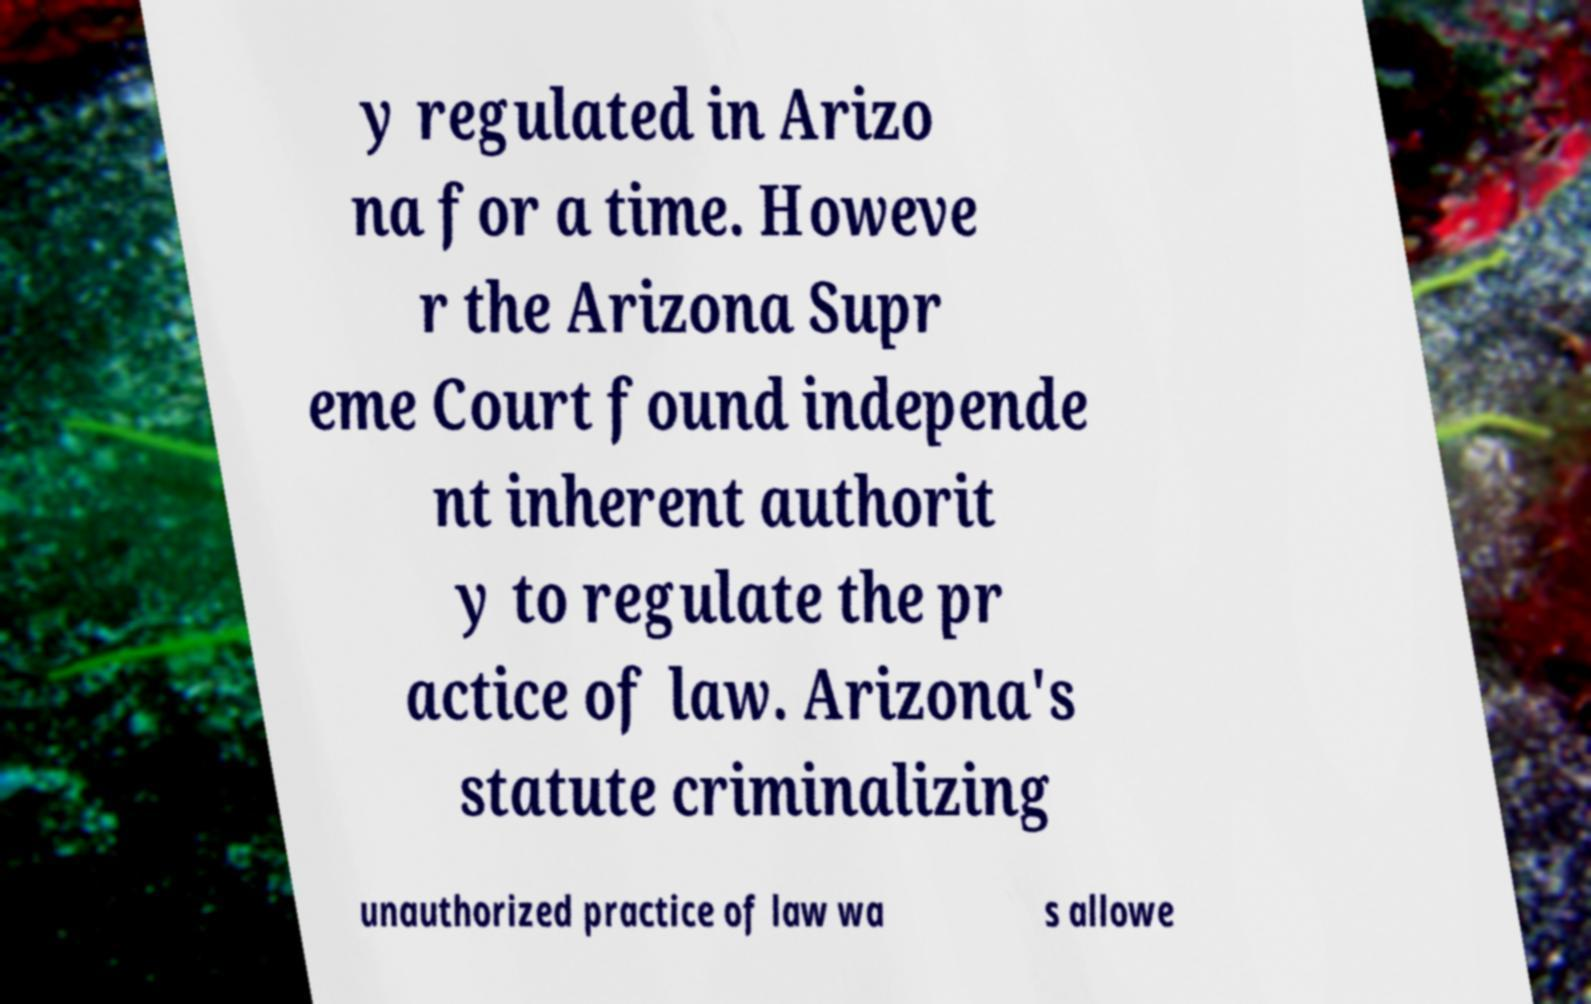Can you accurately transcribe the text from the provided image for me? y regulated in Arizo na for a time. Howeve r the Arizona Supr eme Court found independe nt inherent authorit y to regulate the pr actice of law. Arizona's statute criminalizing unauthorized practice of law wa s allowe 